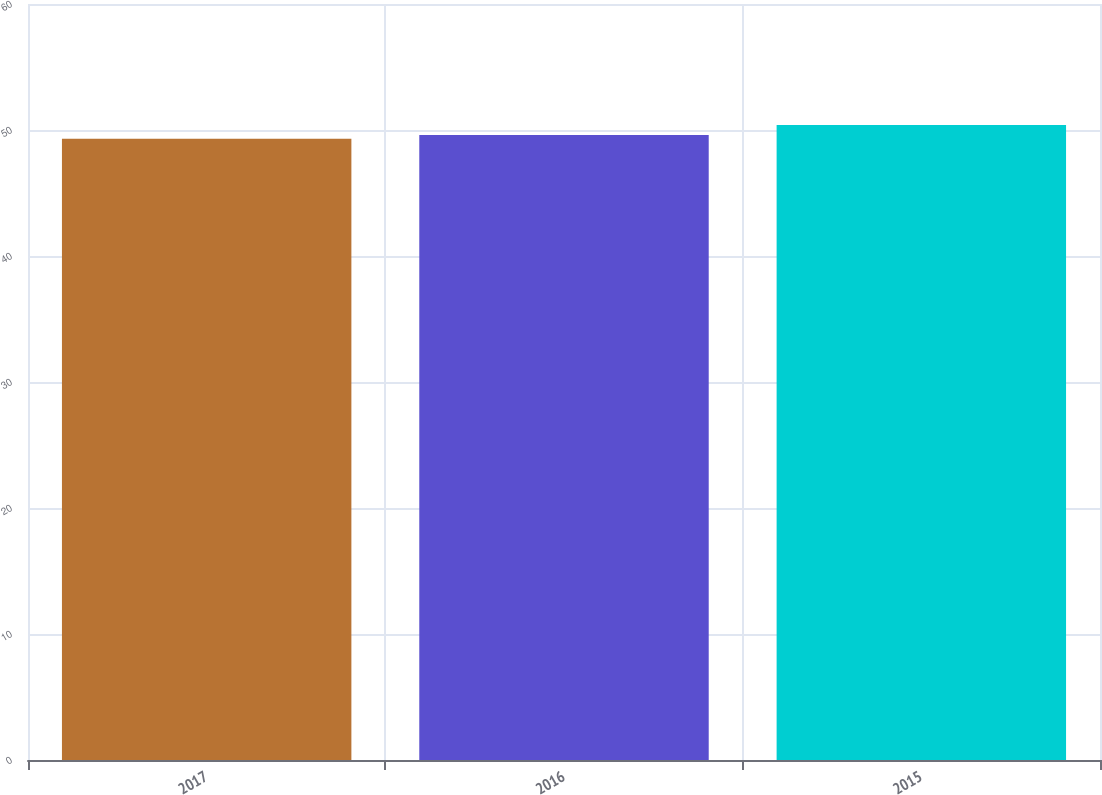Convert chart. <chart><loc_0><loc_0><loc_500><loc_500><bar_chart><fcel>2017<fcel>2016<fcel>2015<nl><fcel>49.3<fcel>49.6<fcel>50.4<nl></chart> 